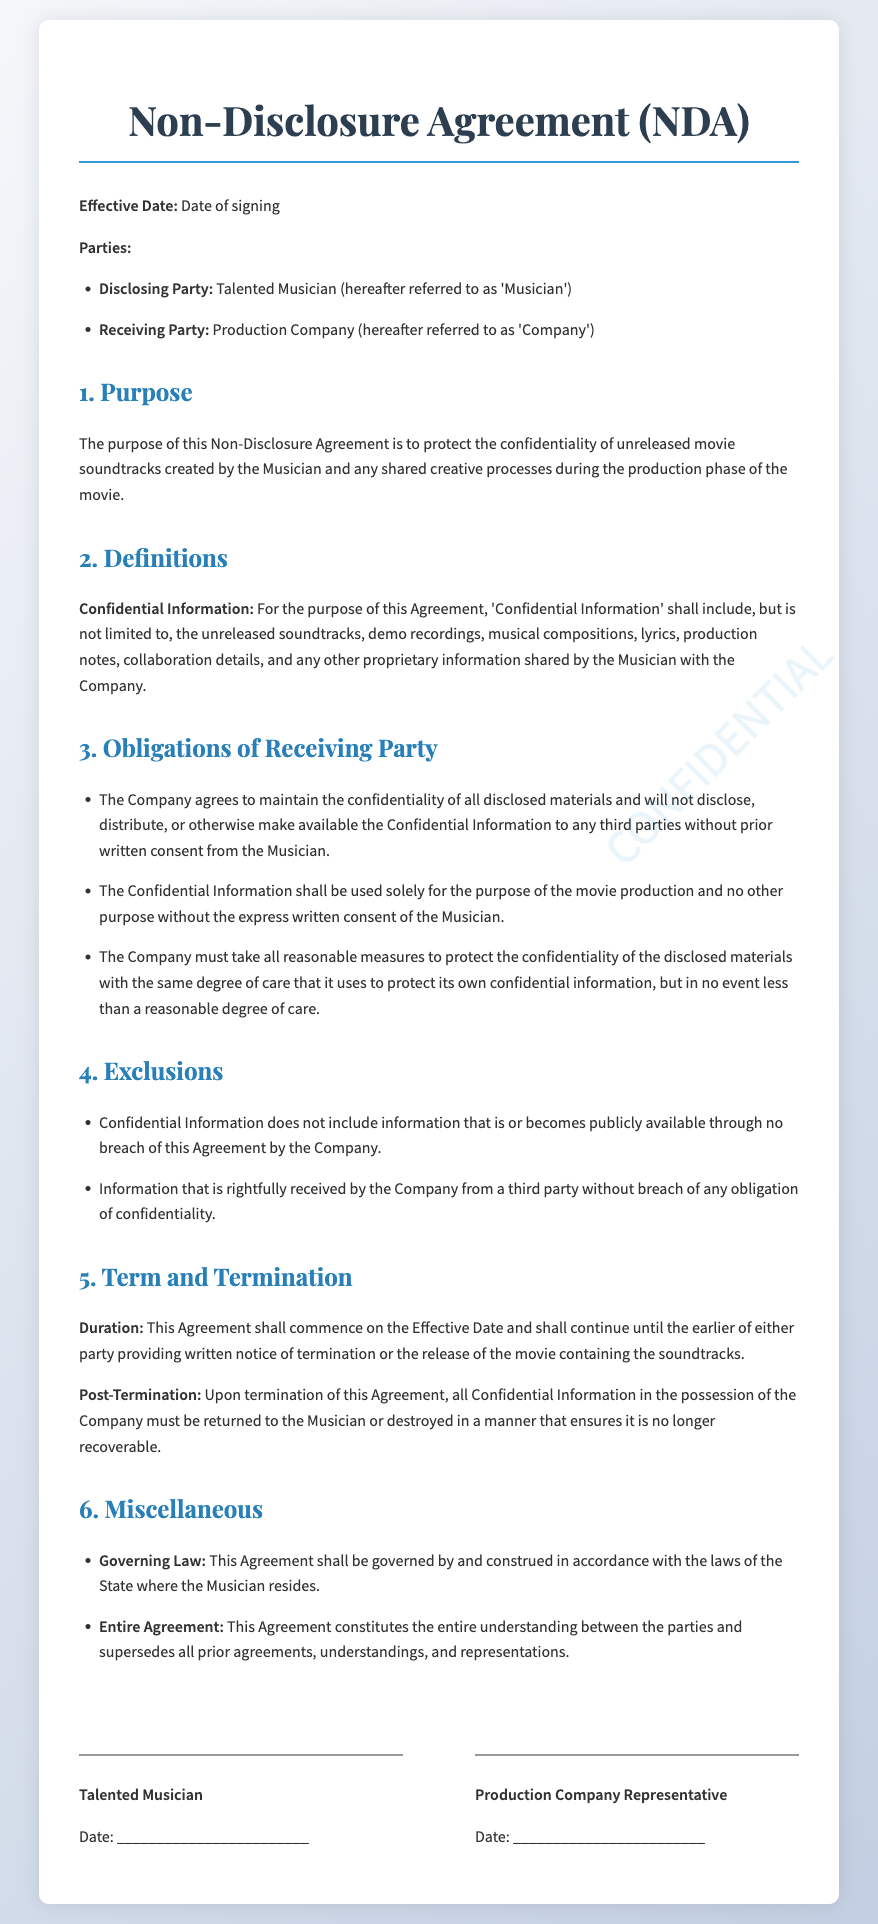What is the effective date? The effective date is mentioned as "Date of signing," indicating that it will vary based on when the contract is signed.
Answer: Date of signing Who is the disclosing party? The disclosing party is defined in the document as the "Talented Musician."
Answer: Talented Musician What must the receiving party do with confidential information after termination? The document states that upon termination, all confidential information must be either returned or destroyed.
Answer: Returned or destroyed What is included in the definition of confidential information? The document specifies that confidential information includes unreleased soundtracks, demo recordings, and other proprietary information shared.
Answer: Unreleased soundtracks, demo recordings What governs the agreement? The governing law section states that the agreement will be governed by the laws of the state where the musician resides.
Answer: The State where the Musician resides What is the duration of the agreement? The agreement commences on the effective date and continues until either party provides written notice or the movie is released.
Answer: Until written notice or the movie release What happens if the confidential information becomes publicly available? The document clarifies that confidential information does not include information that becomes publicly available through no breach of the agreement.
Answer: Does not include publicly available information What must the receiving party do with the confidential information? The receiving party must maintain the confidentiality of all disclosed materials as per the obligations stated in the document.
Answer: Maintain confidentiality 